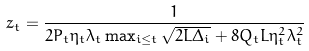<formula> <loc_0><loc_0><loc_500><loc_500>z _ { t } & = \frac { 1 } { 2 P _ { t } \eta _ { t } \lambda _ { t } \max _ { i \leq t } \sqrt { 2 L \Delta _ { i } } + 8 Q _ { t } L \eta _ { t } ^ { 2 } \lambda _ { t } ^ { 2 } }</formula> 